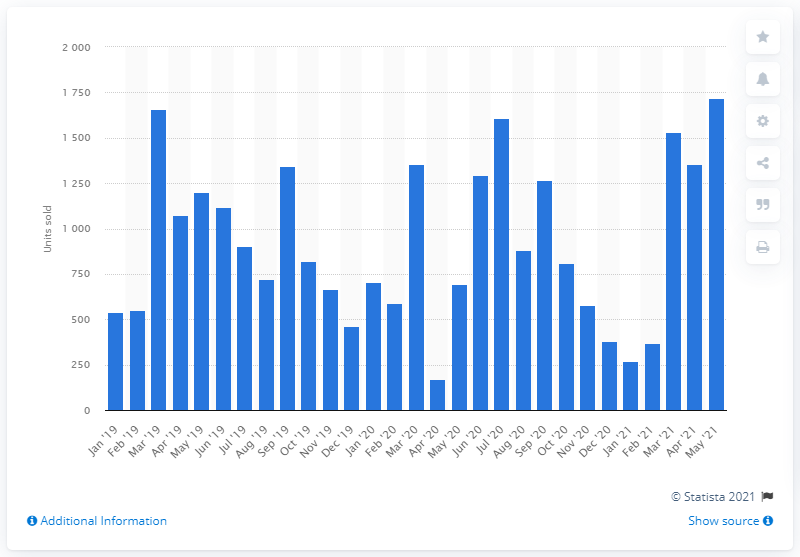Give some essential details in this illustration. In April of 2020, a total of 173 new Yamaha motorcycles were registered. 